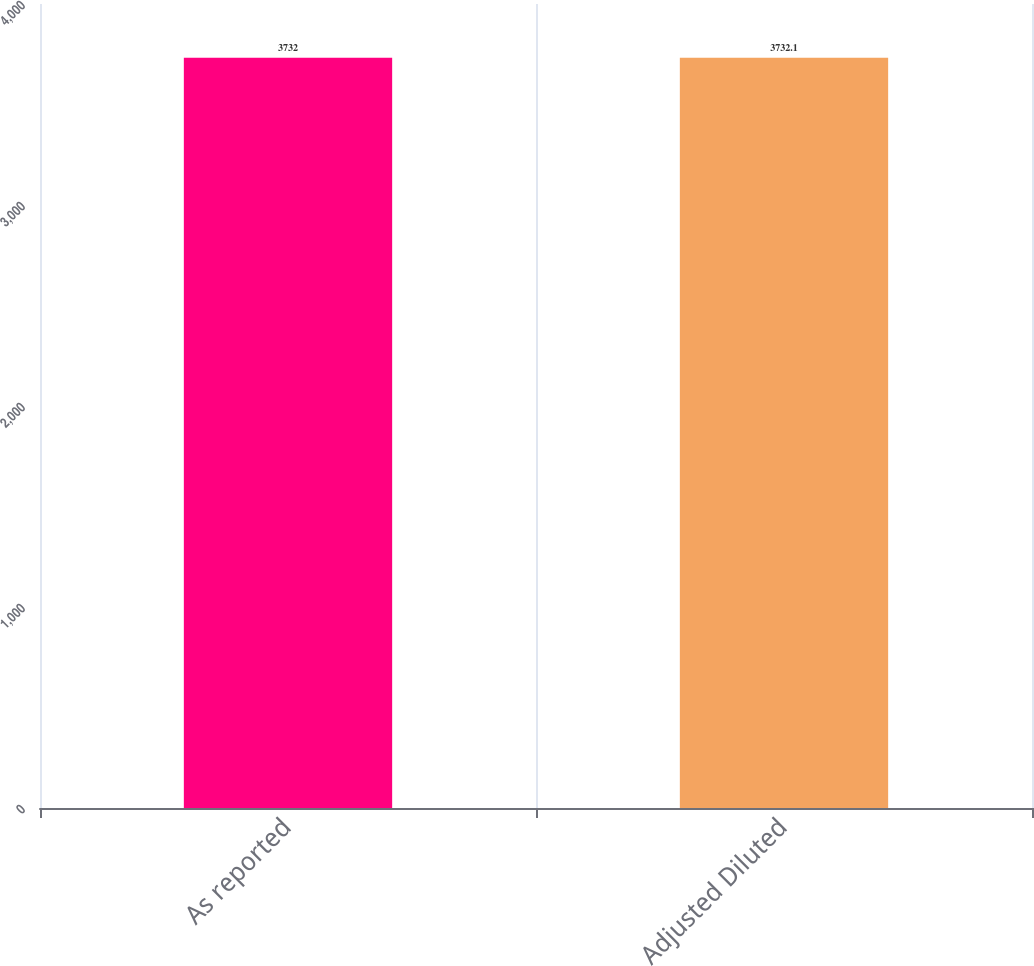Convert chart. <chart><loc_0><loc_0><loc_500><loc_500><bar_chart><fcel>As reported<fcel>Adjusted Diluted<nl><fcel>3732<fcel>3732.1<nl></chart> 